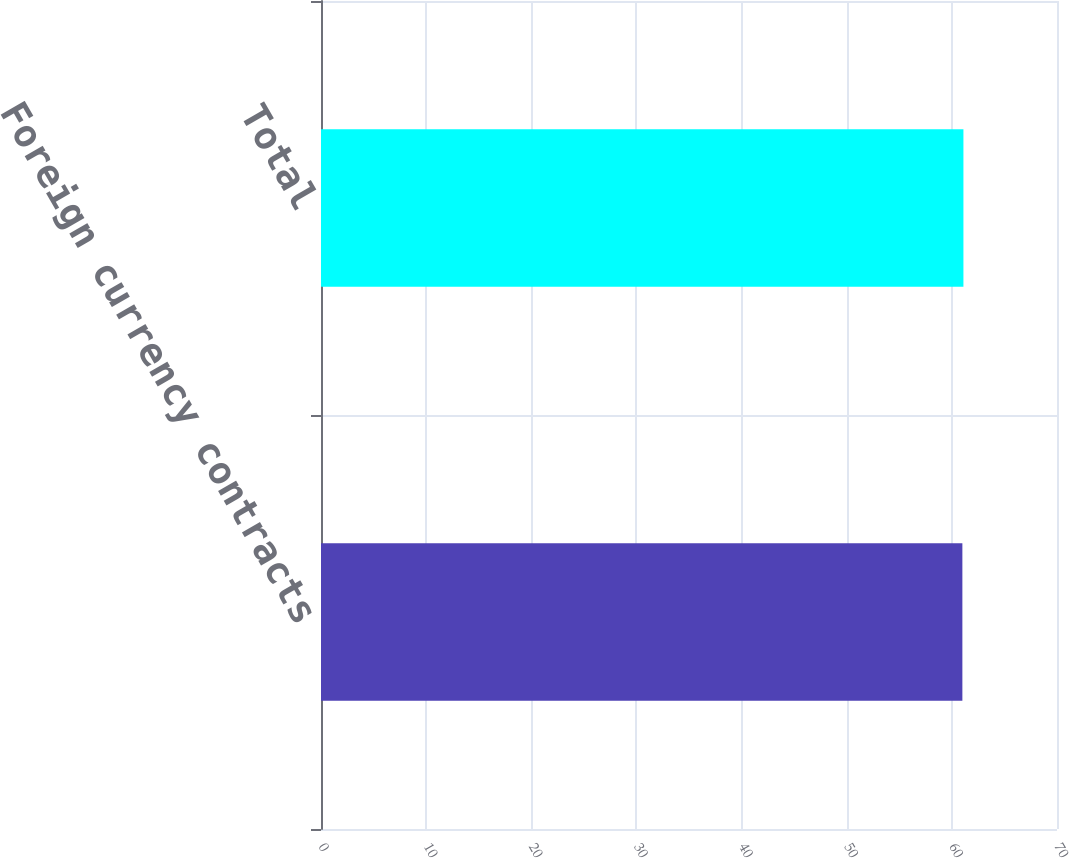Convert chart. <chart><loc_0><loc_0><loc_500><loc_500><bar_chart><fcel>Foreign currency contracts<fcel>Total<nl><fcel>61<fcel>61.1<nl></chart> 